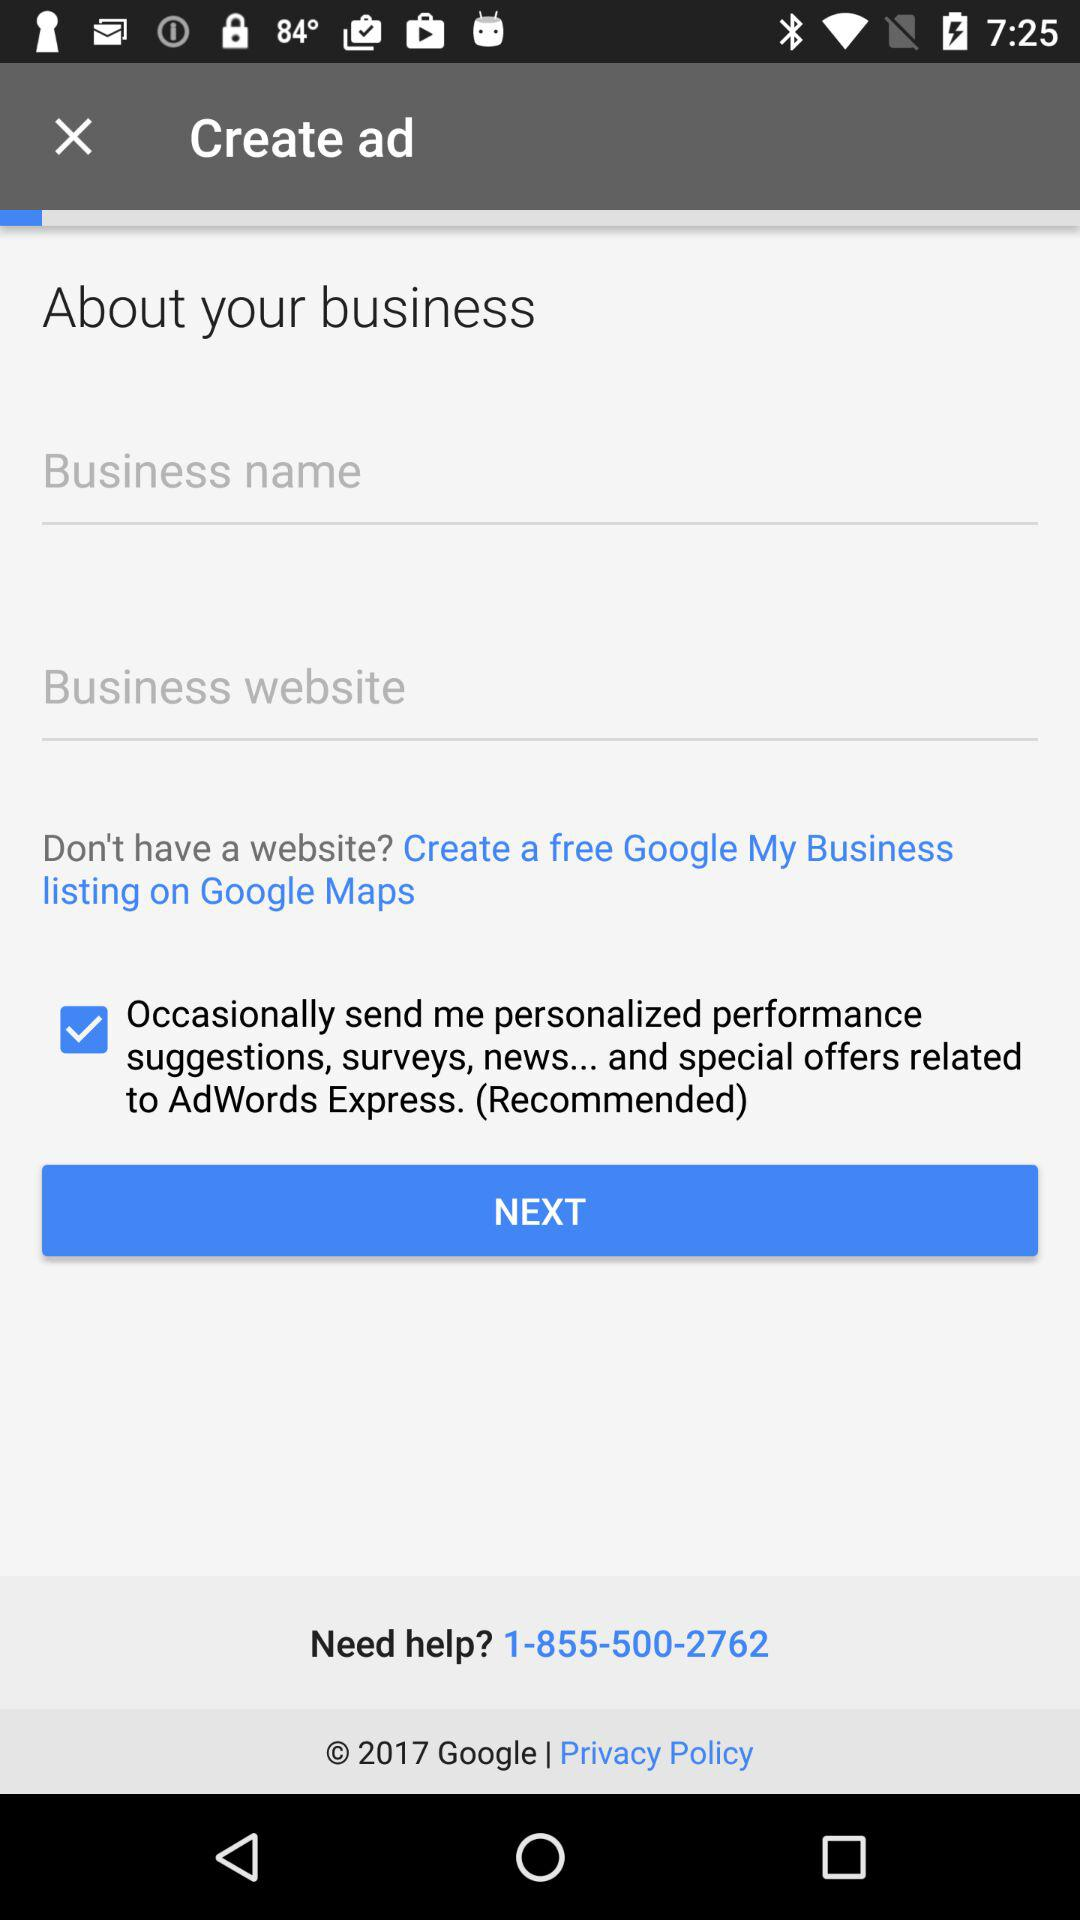What is the helpline number? The helpline number is 1-855-500-2762. 